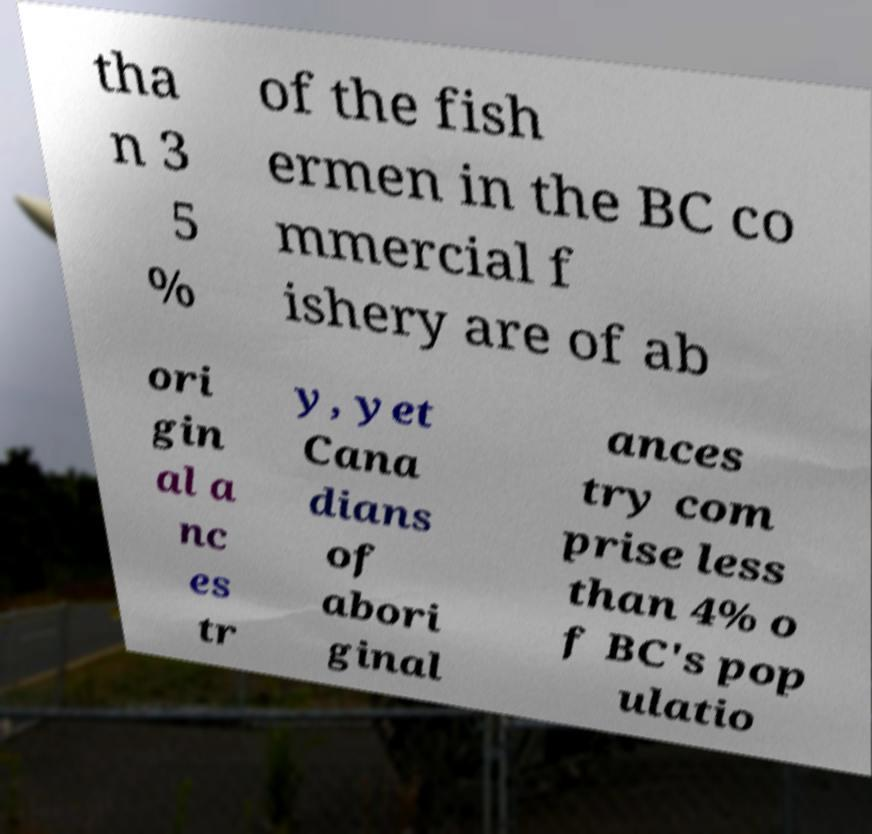Can you accurately transcribe the text from the provided image for me? tha n 3 5 % of the fish ermen in the BC co mmercial f ishery are of ab ori gin al a nc es tr y, yet Cana dians of abori ginal ances try com prise less than 4% o f BC's pop ulatio 